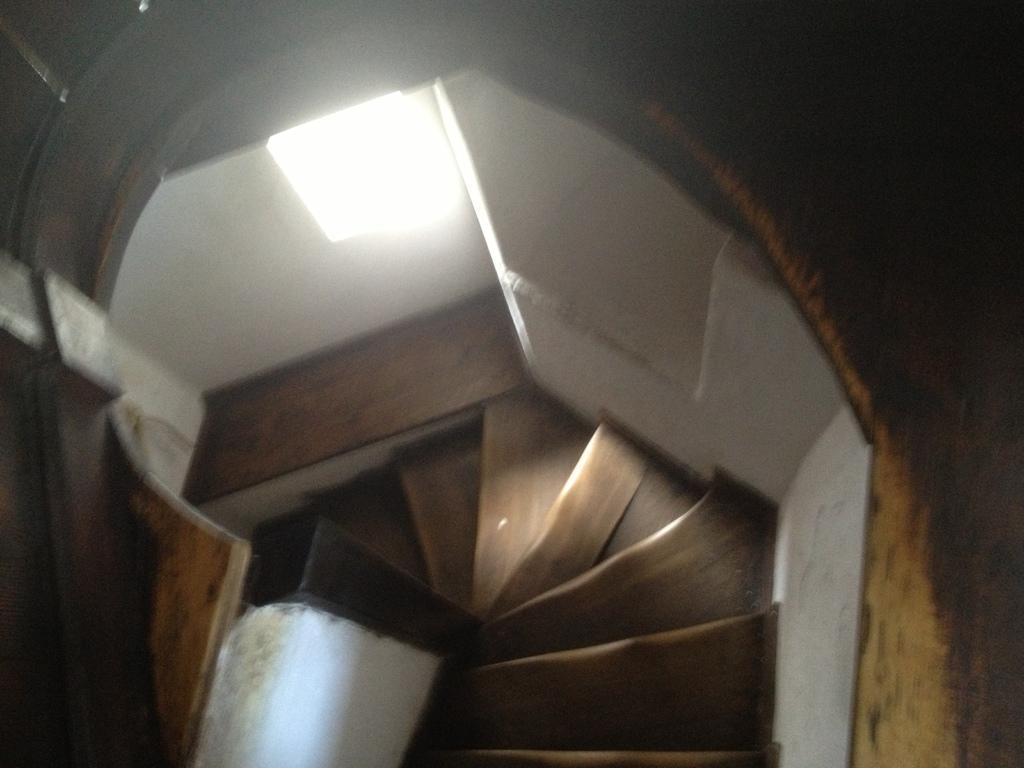Could you give a brief overview of what you see in this image? In the foreground of this image, there is wall, stairs and a light. 